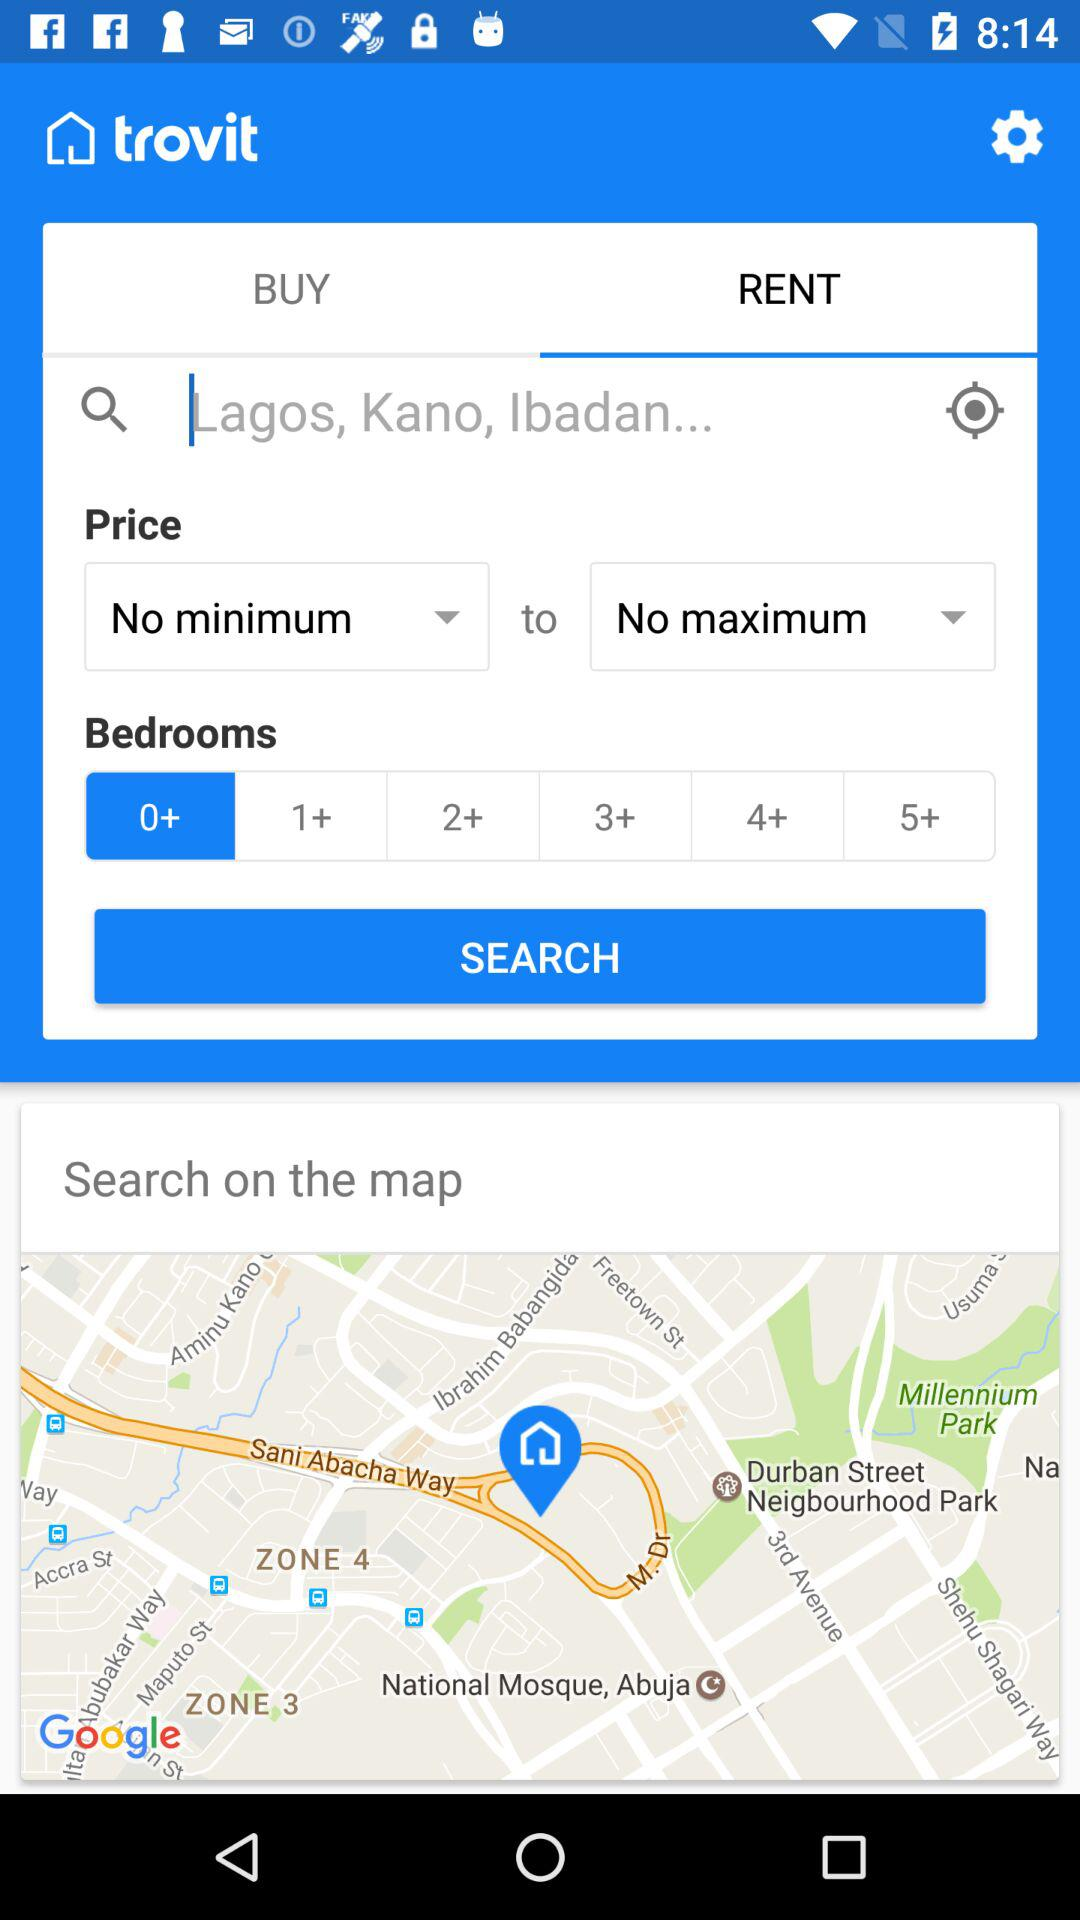Which tab is selected? The selected tab is "RENT". 